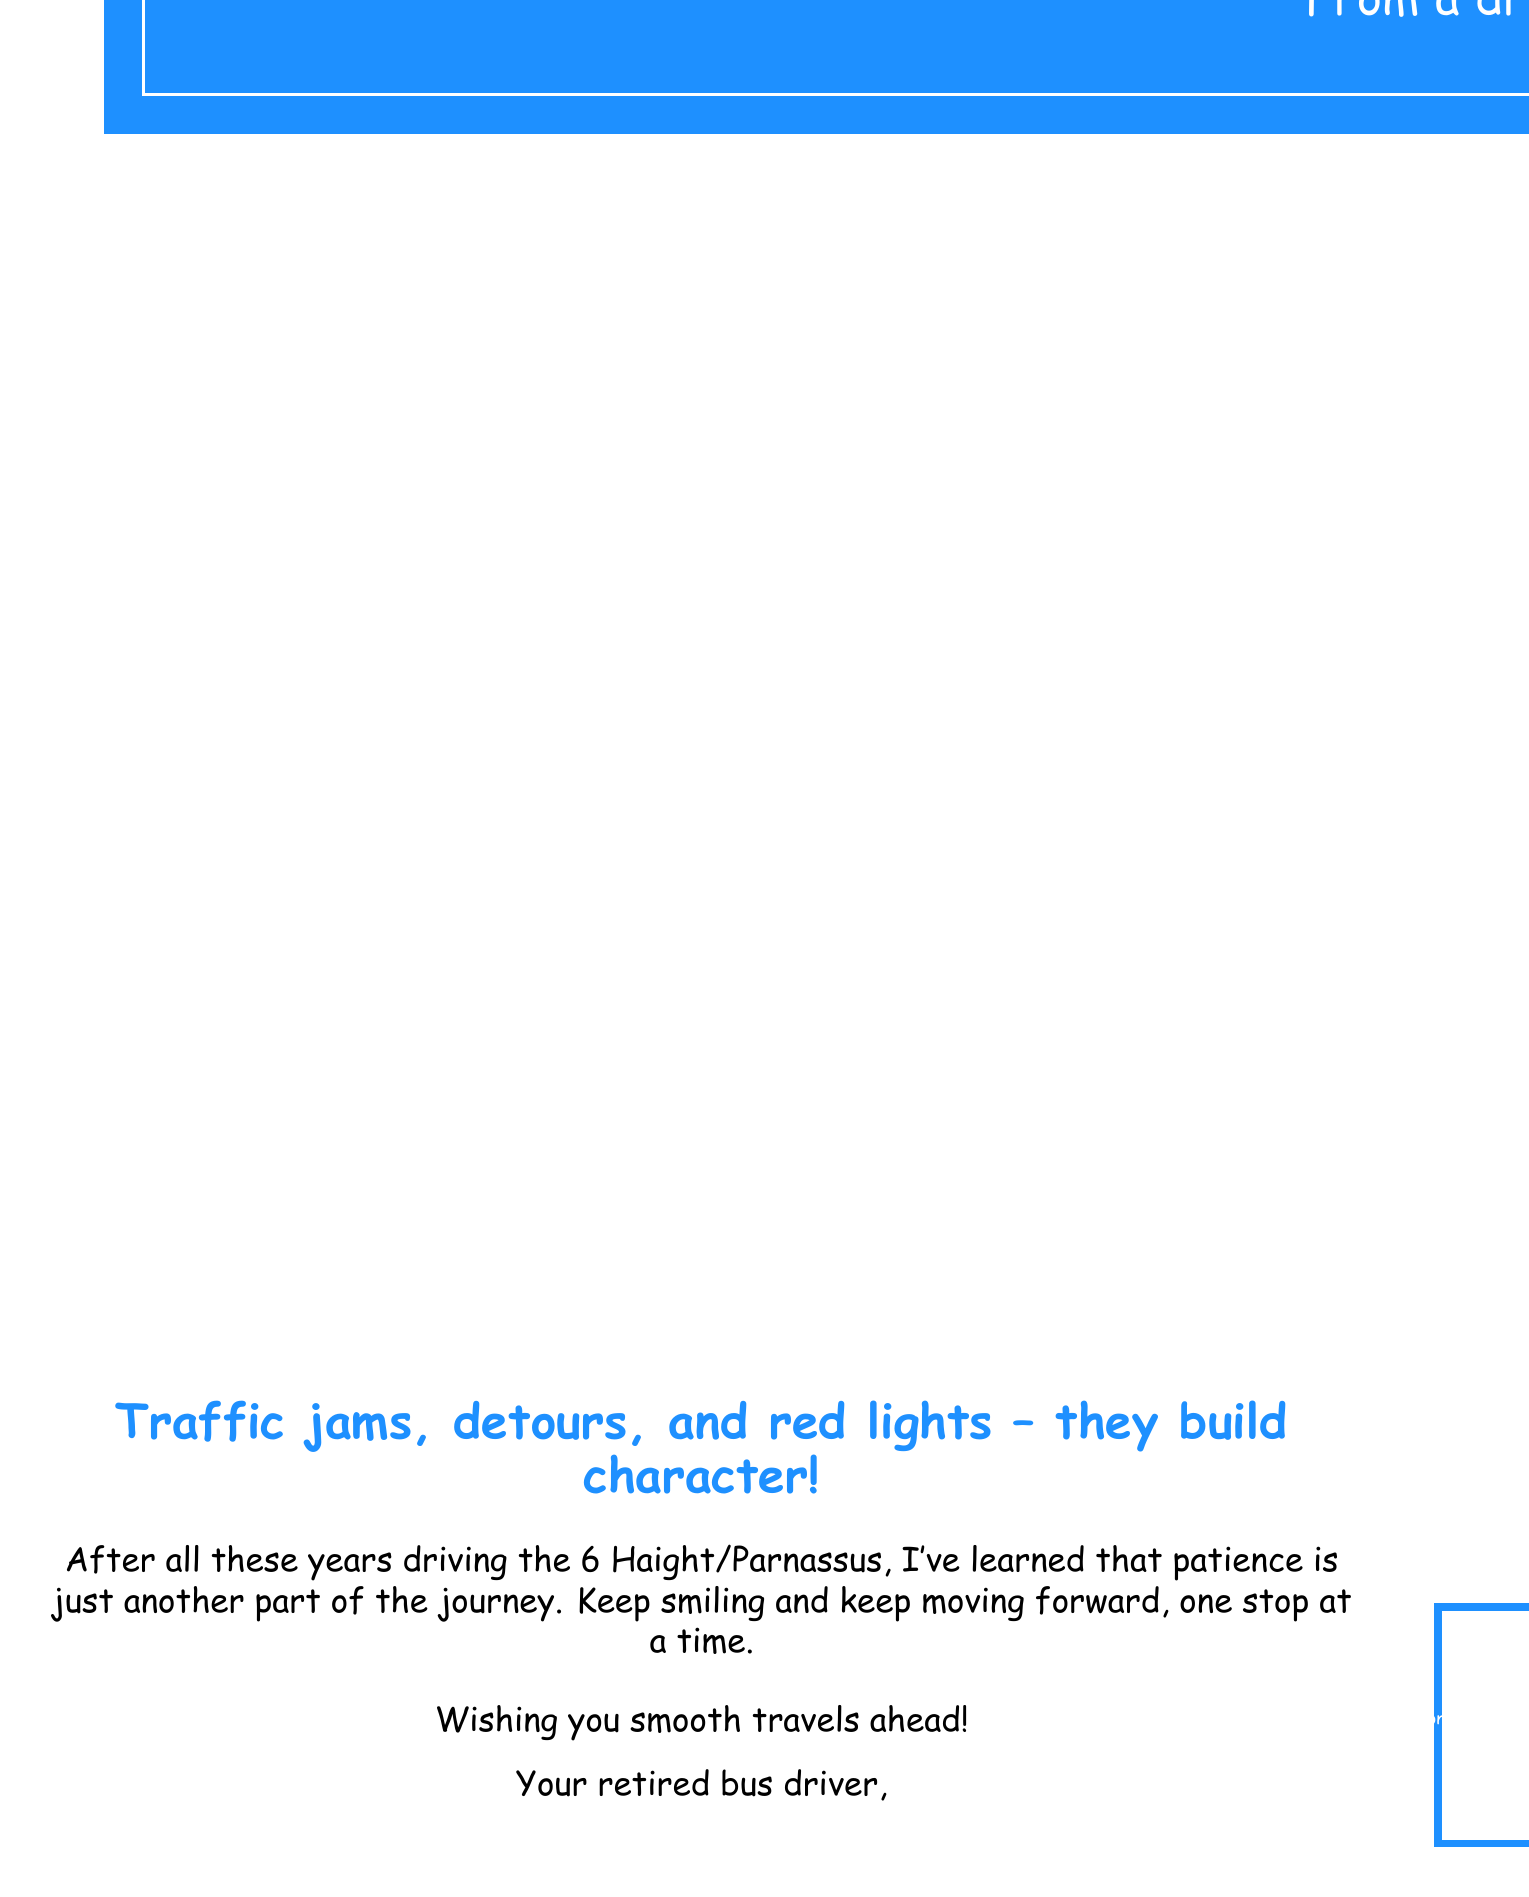What is the main message on the card? The main message is about patience while driving, reflecting a seasoned driver's experience.
Answer: Patience is a virtue... Especially behind the wheel! What color is the card's background? The card's background color is blue, specifically a shade referred to as "busblue."
Answer: busblue Which bus line did the driver operate? The greeting card mentions the specific bus line operated by the driver throughout their career.
Answer: 6 Haight/Parnassus What is the humorous element of the card? The card features a cartoon bus stuck in traffic, which adds a humorous touch to the theme of patience.
Answer: Cartoon bus stuck in traffic What phrase suggests that the sender is experienced? The phrase indicates that the sender has considerable experience as a bus driver.
Answer: a driver who has seen it all What is the advice given for dealing with traffic? The advice emphasizes maintaining a positive attitude despite traffic challenges.
Answer: Keep smiling and keep moving forward What phrase is mentioned to wish the recipient well? This phrase conveys the sender's hopes for enjoyable and easy travels for the recipient.
Answer: Wishing you smooth travels ahead! 